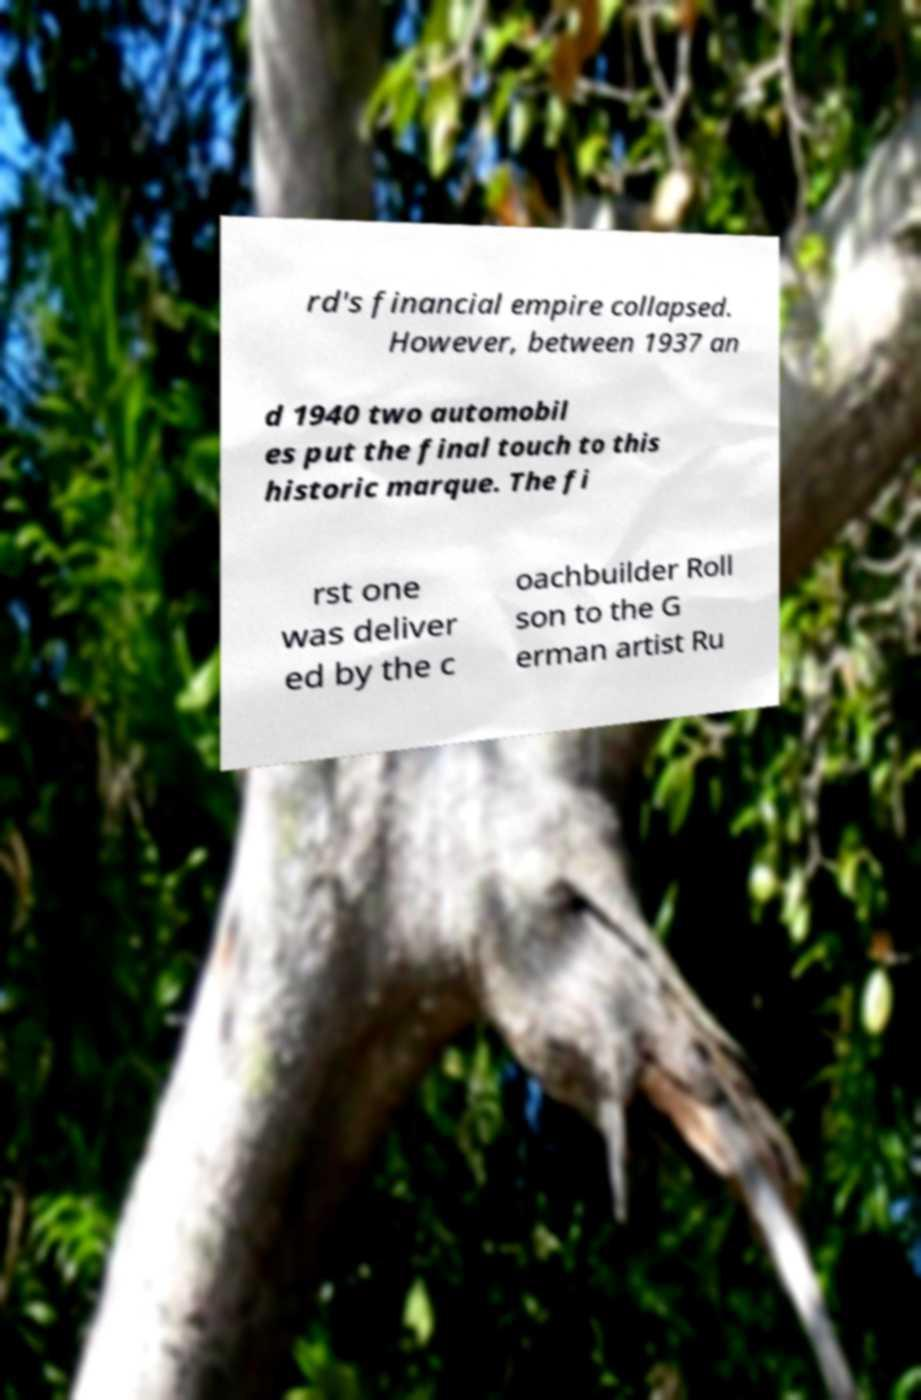Can you accurately transcribe the text from the provided image for me? rd's financial empire collapsed. However, between 1937 an d 1940 two automobil es put the final touch to this historic marque. The fi rst one was deliver ed by the c oachbuilder Roll son to the G erman artist Ru 